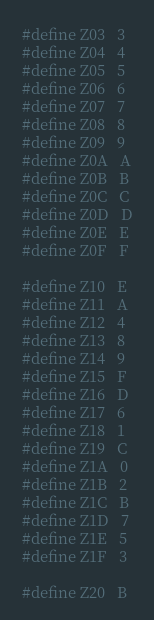<code> <loc_0><loc_0><loc_500><loc_500><_Cuda_>#define Z03   3
#define Z04   4
#define Z05   5
#define Z06   6
#define Z07   7
#define Z08   8
#define Z09   9
#define Z0A   A
#define Z0B   B
#define Z0C   C
#define Z0D   D
#define Z0E   E
#define Z0F   F

#define Z10   E
#define Z11   A
#define Z12   4
#define Z13   8
#define Z14   9
#define Z15   F
#define Z16   D
#define Z17   6
#define Z18   1
#define Z19   C
#define Z1A   0
#define Z1B   2
#define Z1C   B
#define Z1D   7
#define Z1E   5
#define Z1F   3

#define Z20   B</code> 